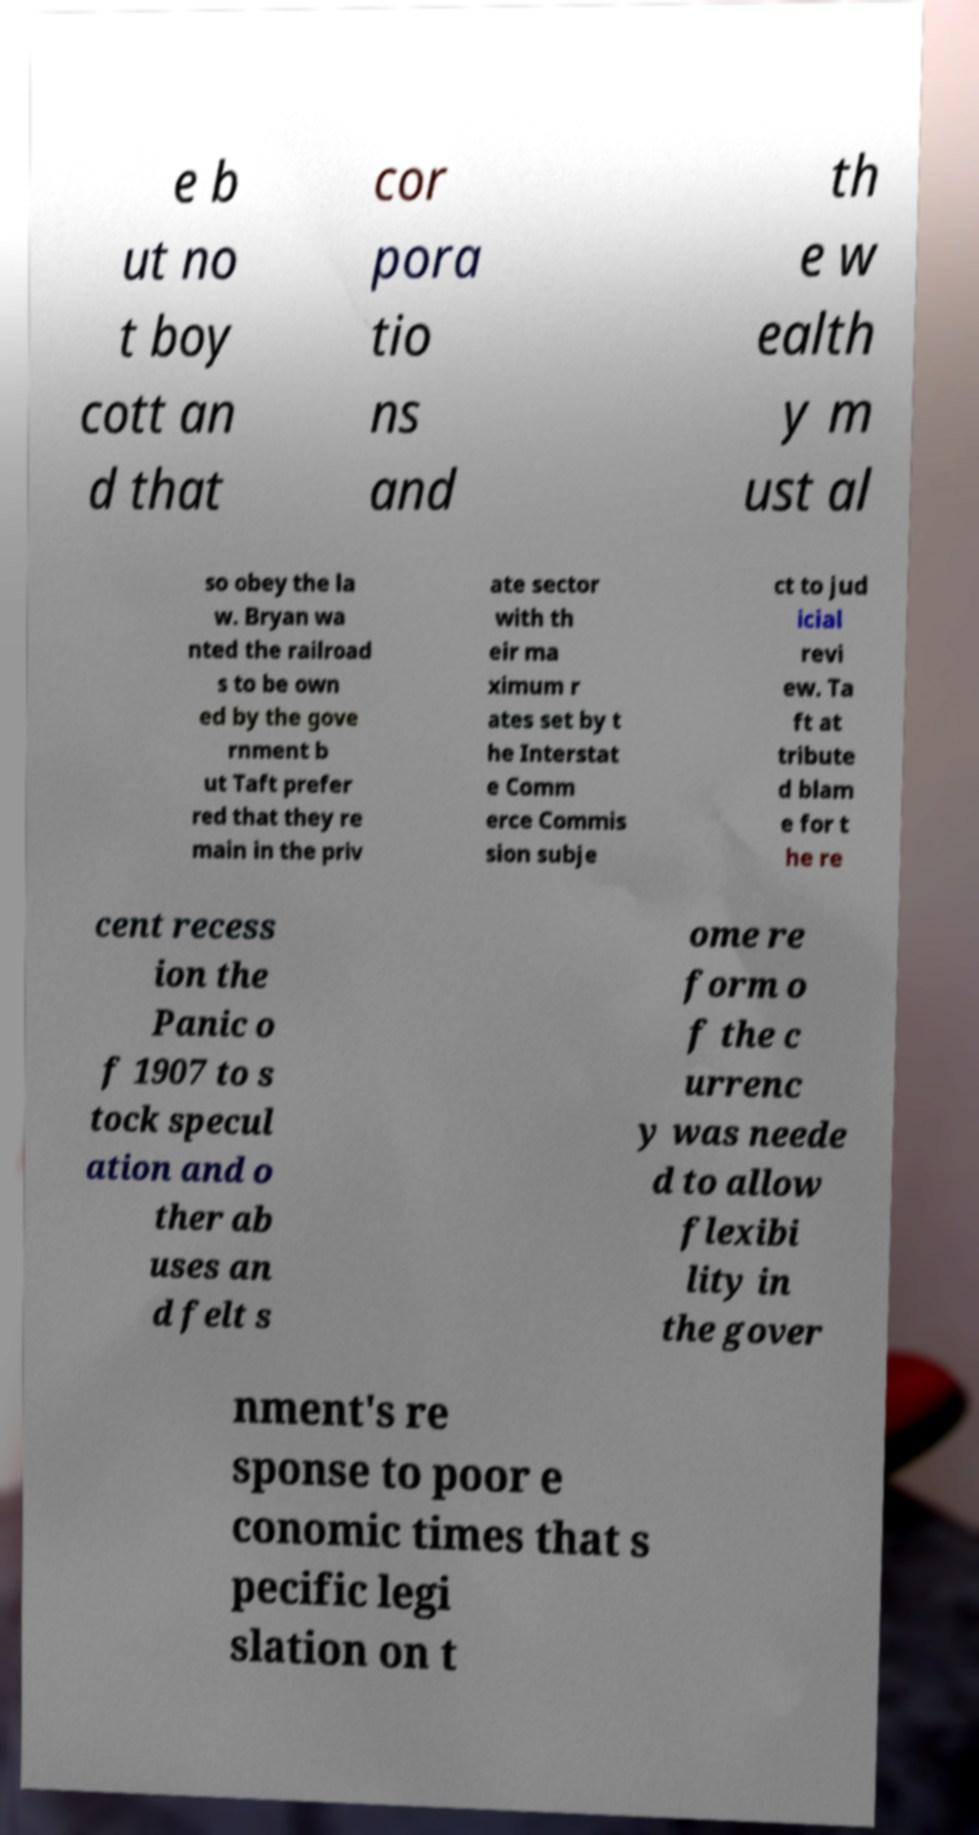Can you read and provide the text displayed in the image?This photo seems to have some interesting text. Can you extract and type it out for me? e b ut no t boy cott an d that cor pora tio ns and th e w ealth y m ust al so obey the la w. Bryan wa nted the railroad s to be own ed by the gove rnment b ut Taft prefer red that they re main in the priv ate sector with th eir ma ximum r ates set by t he Interstat e Comm erce Commis sion subje ct to jud icial revi ew. Ta ft at tribute d blam e for t he re cent recess ion the Panic o f 1907 to s tock specul ation and o ther ab uses an d felt s ome re form o f the c urrenc y was neede d to allow flexibi lity in the gover nment's re sponse to poor e conomic times that s pecific legi slation on t 